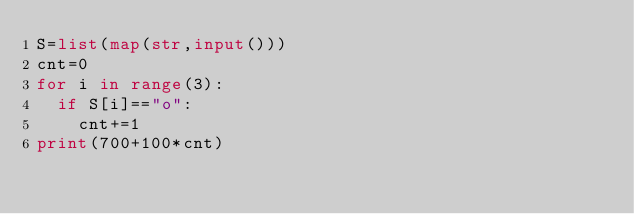Convert code to text. <code><loc_0><loc_0><loc_500><loc_500><_Python_>S=list(map(str,input()))
cnt=0
for i in range(3):
  if S[i]=="o":
    cnt+=1
print(700+100*cnt)</code> 